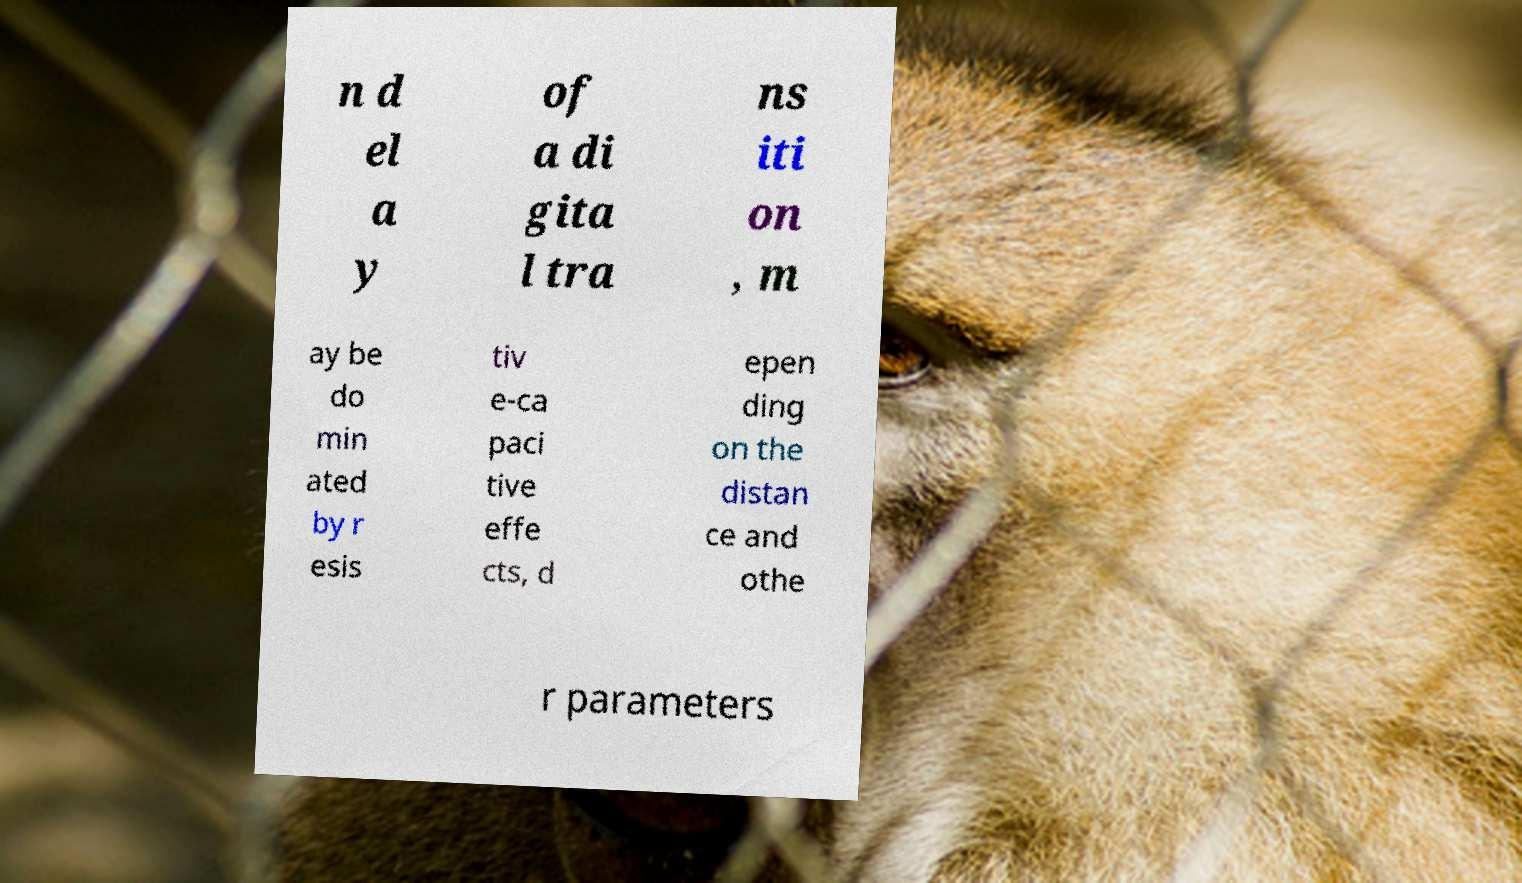Can you accurately transcribe the text from the provided image for me? n d el a y of a di gita l tra ns iti on , m ay be do min ated by r esis tiv e-ca paci tive effe cts, d epen ding on the distan ce and othe r parameters 